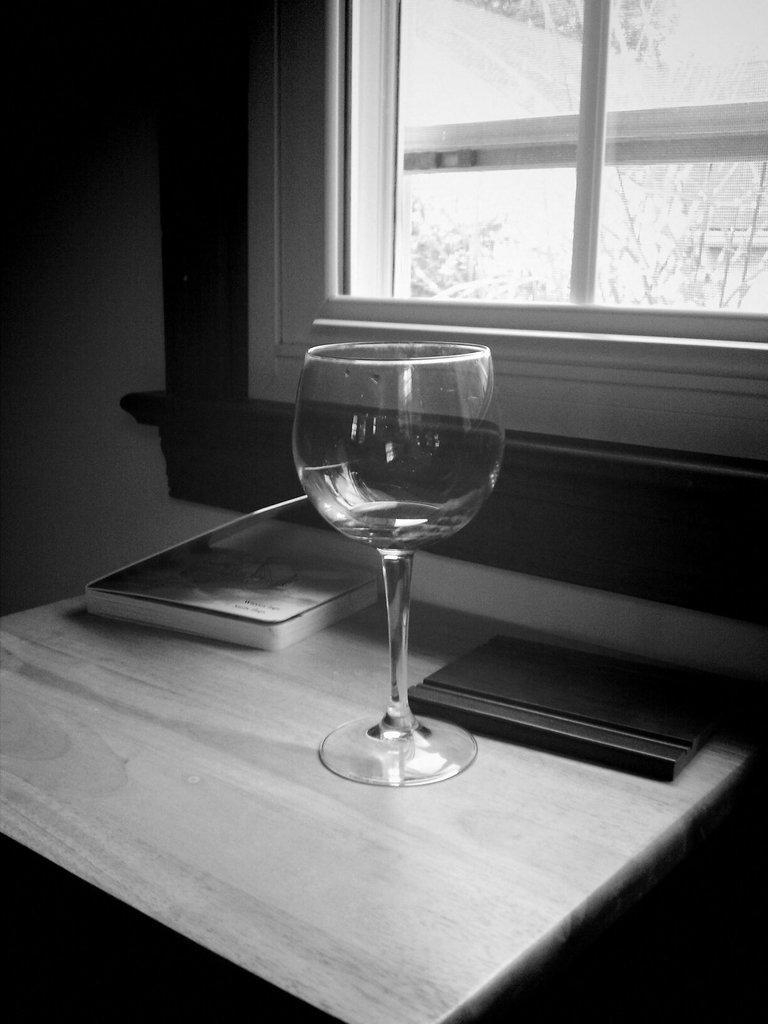In one or two sentences, can you explain what this image depicts? In this picture we can see a table which consists of empty glass and two book and also we can see a window. 